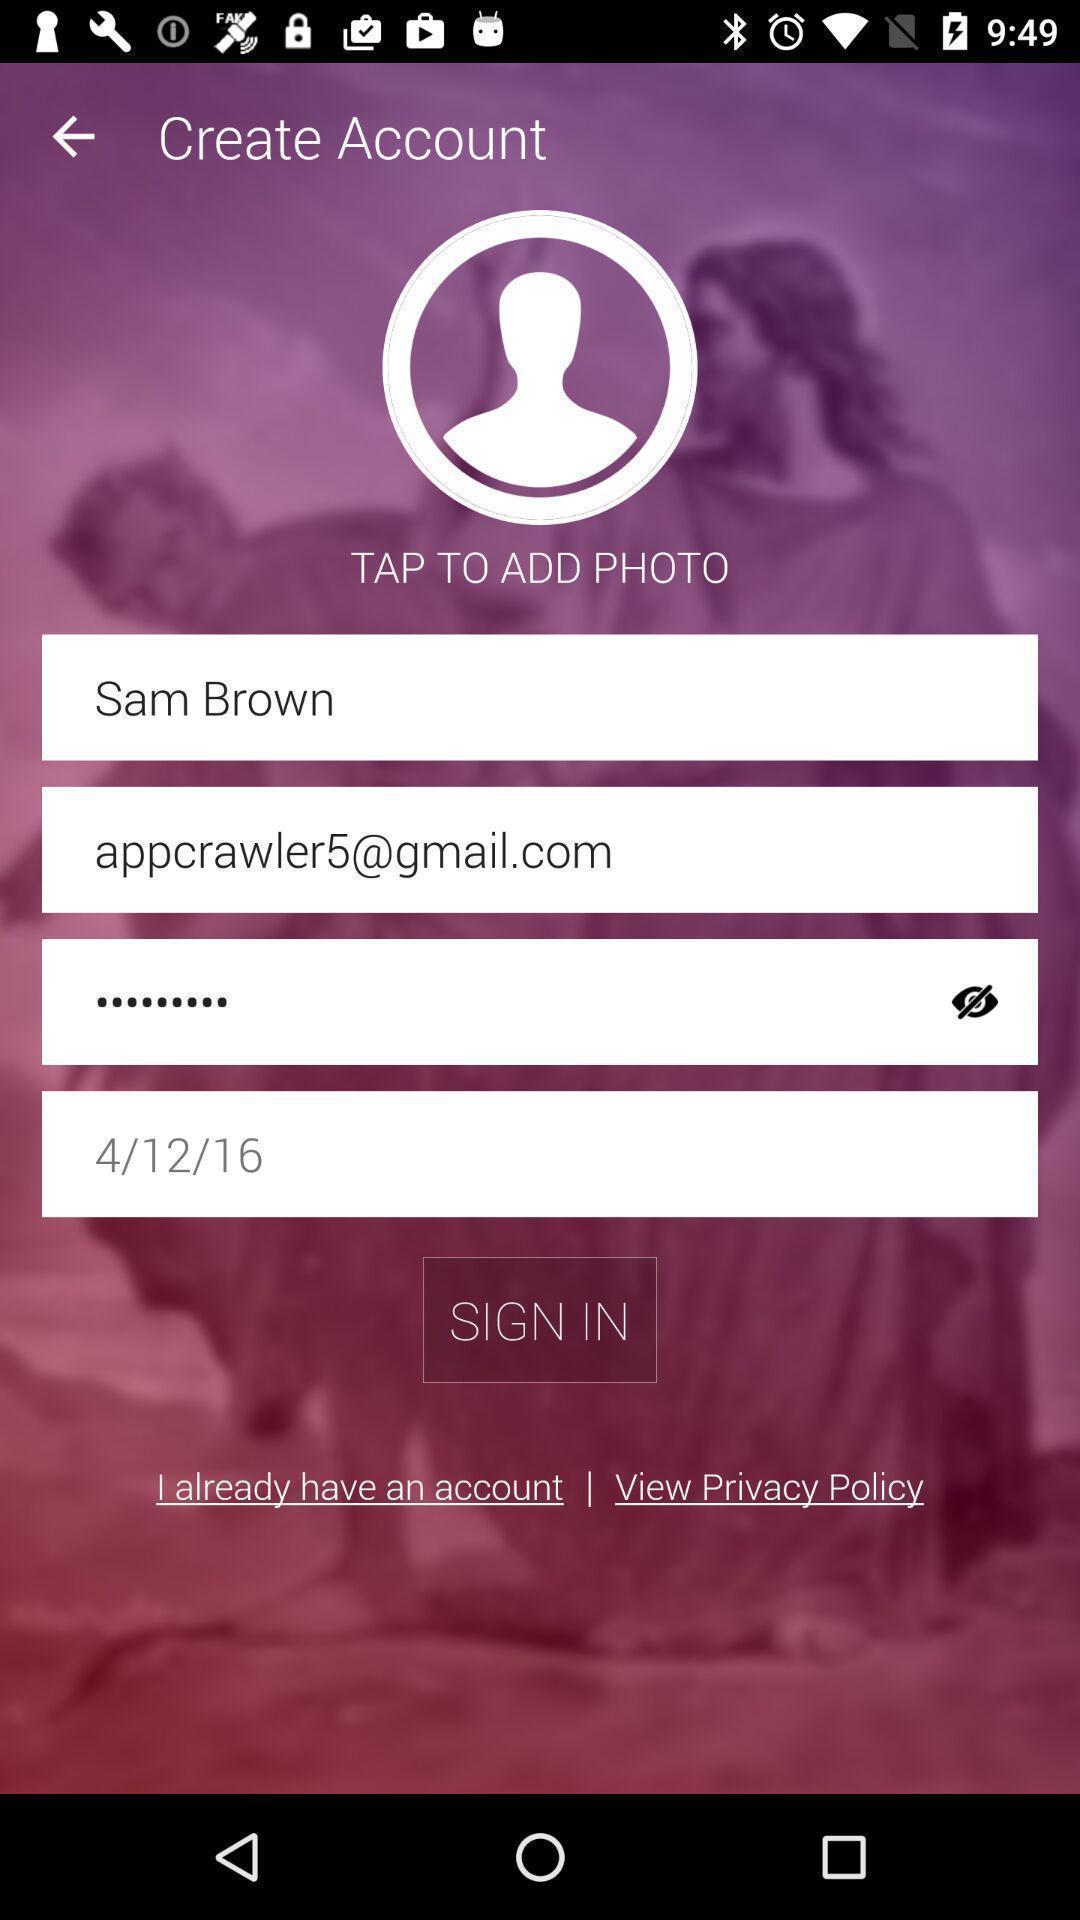Describe the visual elements of this screenshot. Sign in page for the application with entry details. 